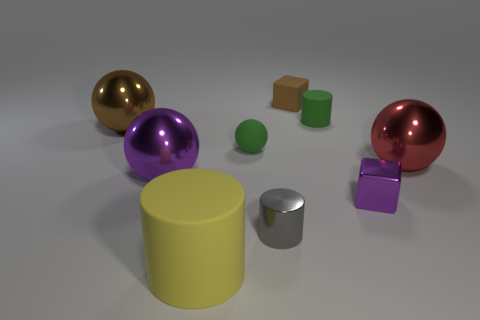Subtract all big rubber cylinders. How many cylinders are left? 2 Subtract all brown balls. How many balls are left? 3 Subtract all blocks. How many objects are left? 7 Add 1 green spheres. How many objects exist? 10 Subtract 1 green cylinders. How many objects are left? 8 Subtract 1 spheres. How many spheres are left? 3 Subtract all red cylinders. Subtract all yellow cubes. How many cylinders are left? 3 Subtract all purple cylinders. How many yellow spheres are left? 0 Subtract all large red shiny things. Subtract all metal balls. How many objects are left? 5 Add 2 yellow cylinders. How many yellow cylinders are left? 3 